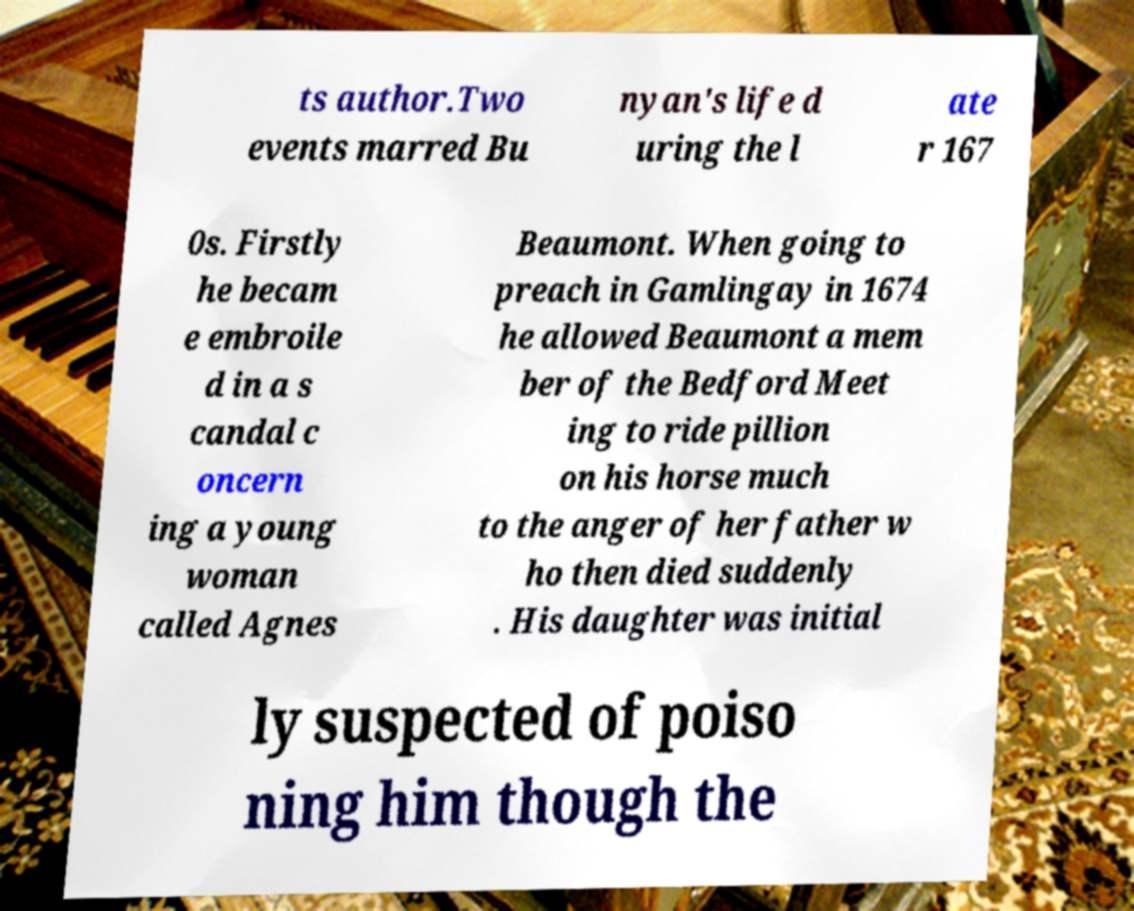What messages or text are displayed in this image? I need them in a readable, typed format. ts author.Two events marred Bu nyan's life d uring the l ate r 167 0s. Firstly he becam e embroile d in a s candal c oncern ing a young woman called Agnes Beaumont. When going to preach in Gamlingay in 1674 he allowed Beaumont a mem ber of the Bedford Meet ing to ride pillion on his horse much to the anger of her father w ho then died suddenly . His daughter was initial ly suspected of poiso ning him though the 